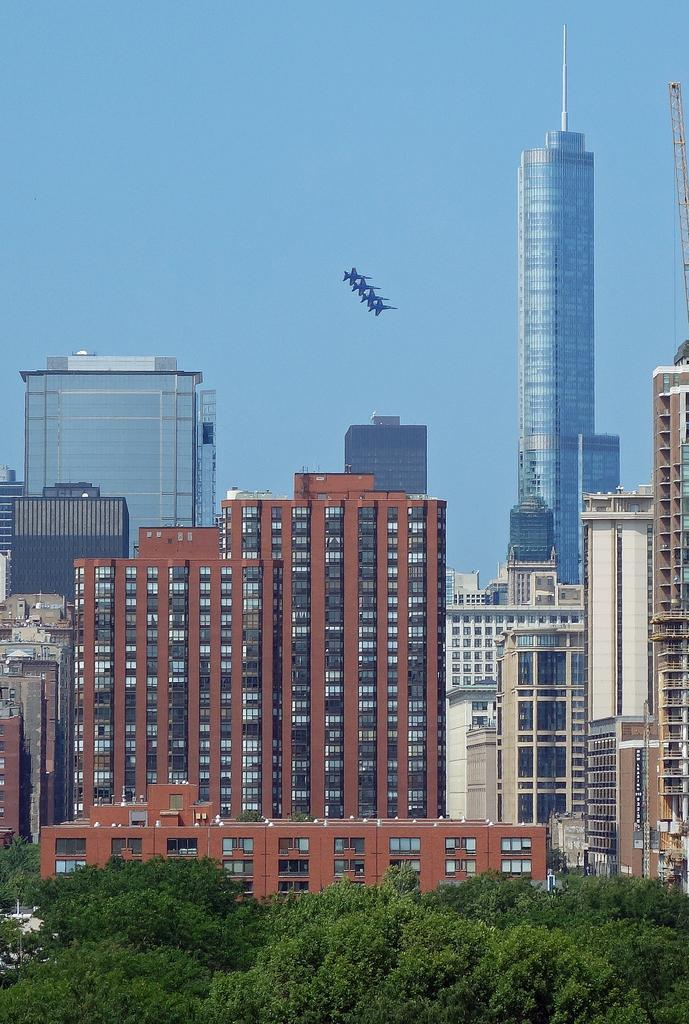What type of vegetation can be seen in the image? There are trees in the image. What is the color of the trees? The trees are green. What can be seen in the background of the image? There are buildings in the background of the image. What colors are the buildings? The buildings are in brown and white colors. What else is visible in the image besides trees and buildings? There are aircraft visible in the image. What is the color of the sky in the image? The sky is blue. What type of square is being used for the operation in the image? There is no square or operation present in the image; it features trees, buildings, aircraft, and a blue sky. 